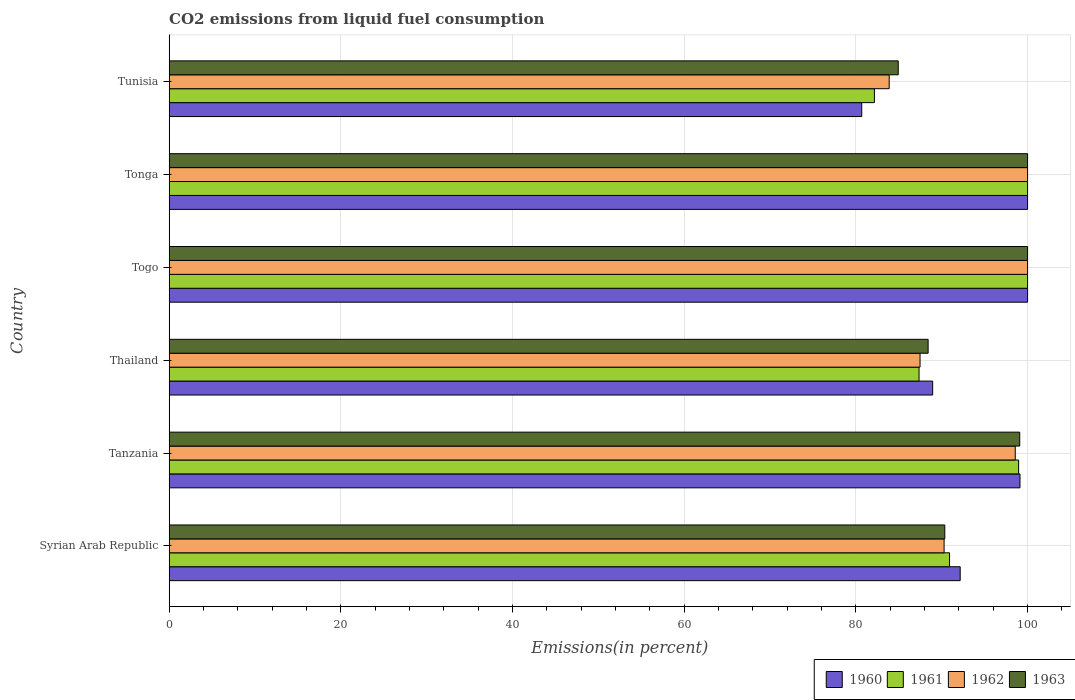How many different coloured bars are there?
Make the answer very short. 4. Are the number of bars per tick equal to the number of legend labels?
Give a very brief answer. Yes. What is the label of the 6th group of bars from the top?
Offer a very short reply. Syrian Arab Republic. In how many cases, is the number of bars for a given country not equal to the number of legend labels?
Keep it short and to the point. 0. Across all countries, what is the maximum total CO2 emitted in 1963?
Keep it short and to the point. 100. Across all countries, what is the minimum total CO2 emitted in 1962?
Your response must be concise. 83.88. In which country was the total CO2 emitted in 1962 maximum?
Your answer should be very brief. Togo. In which country was the total CO2 emitted in 1961 minimum?
Offer a very short reply. Tunisia. What is the total total CO2 emitted in 1960 in the graph?
Your response must be concise. 560.89. What is the difference between the total CO2 emitted in 1961 in Tanzania and that in Thailand?
Provide a succinct answer. 11.6. What is the difference between the total CO2 emitted in 1961 in Togo and the total CO2 emitted in 1962 in Thailand?
Your answer should be very brief. 12.53. What is the average total CO2 emitted in 1960 per country?
Offer a terse response. 93.48. What is the difference between the total CO2 emitted in 1960 and total CO2 emitted in 1961 in Syrian Arab Republic?
Offer a very short reply. 1.24. In how many countries, is the total CO2 emitted in 1960 greater than 72 %?
Your answer should be compact. 6. What is the ratio of the total CO2 emitted in 1963 in Thailand to that in Tunisia?
Ensure brevity in your answer.  1.04. Is the difference between the total CO2 emitted in 1960 in Thailand and Togo greater than the difference between the total CO2 emitted in 1961 in Thailand and Togo?
Give a very brief answer. Yes. What is the difference between the highest and the lowest total CO2 emitted in 1961?
Your answer should be very brief. 17.84. Is it the case that in every country, the sum of the total CO2 emitted in 1961 and total CO2 emitted in 1962 is greater than the total CO2 emitted in 1963?
Ensure brevity in your answer.  Yes. How many countries are there in the graph?
Your answer should be compact. 6. What is the difference between two consecutive major ticks on the X-axis?
Your answer should be compact. 20. Are the values on the major ticks of X-axis written in scientific E-notation?
Offer a very short reply. No. Does the graph contain any zero values?
Make the answer very short. No. Where does the legend appear in the graph?
Provide a short and direct response. Bottom right. How many legend labels are there?
Provide a succinct answer. 4. What is the title of the graph?
Your answer should be compact. CO2 emissions from liquid fuel consumption. Does "1962" appear as one of the legend labels in the graph?
Your answer should be compact. Yes. What is the label or title of the X-axis?
Provide a succinct answer. Emissions(in percent). What is the label or title of the Y-axis?
Your response must be concise. Country. What is the Emissions(in percent) of 1960 in Syrian Arab Republic?
Your answer should be very brief. 92.15. What is the Emissions(in percent) in 1961 in Syrian Arab Republic?
Your response must be concise. 90.91. What is the Emissions(in percent) of 1962 in Syrian Arab Republic?
Give a very brief answer. 90.27. What is the Emissions(in percent) in 1963 in Syrian Arab Republic?
Give a very brief answer. 90.36. What is the Emissions(in percent) of 1960 in Tanzania?
Make the answer very short. 99.12. What is the Emissions(in percent) of 1961 in Tanzania?
Your answer should be very brief. 98.96. What is the Emissions(in percent) in 1962 in Tanzania?
Ensure brevity in your answer.  98.56. What is the Emissions(in percent) of 1963 in Tanzania?
Offer a very short reply. 99.09. What is the Emissions(in percent) in 1960 in Thailand?
Make the answer very short. 88.94. What is the Emissions(in percent) in 1961 in Thailand?
Keep it short and to the point. 87.36. What is the Emissions(in percent) in 1962 in Thailand?
Your answer should be compact. 87.47. What is the Emissions(in percent) in 1963 in Thailand?
Provide a short and direct response. 88.41. What is the Emissions(in percent) of 1960 in Togo?
Give a very brief answer. 100. What is the Emissions(in percent) in 1961 in Tonga?
Offer a terse response. 100. What is the Emissions(in percent) of 1963 in Tonga?
Keep it short and to the point. 100. What is the Emissions(in percent) in 1960 in Tunisia?
Offer a very short reply. 80.68. What is the Emissions(in percent) of 1961 in Tunisia?
Ensure brevity in your answer.  82.16. What is the Emissions(in percent) in 1962 in Tunisia?
Your response must be concise. 83.88. What is the Emissions(in percent) of 1963 in Tunisia?
Offer a terse response. 84.93. Across all countries, what is the maximum Emissions(in percent) in 1961?
Give a very brief answer. 100. Across all countries, what is the maximum Emissions(in percent) in 1963?
Your response must be concise. 100. Across all countries, what is the minimum Emissions(in percent) in 1960?
Keep it short and to the point. 80.68. Across all countries, what is the minimum Emissions(in percent) of 1961?
Your response must be concise. 82.16. Across all countries, what is the minimum Emissions(in percent) in 1962?
Keep it short and to the point. 83.88. Across all countries, what is the minimum Emissions(in percent) of 1963?
Make the answer very short. 84.93. What is the total Emissions(in percent) of 1960 in the graph?
Make the answer very short. 560.89. What is the total Emissions(in percent) of 1961 in the graph?
Ensure brevity in your answer.  559.38. What is the total Emissions(in percent) of 1962 in the graph?
Provide a succinct answer. 560.19. What is the total Emissions(in percent) of 1963 in the graph?
Give a very brief answer. 562.79. What is the difference between the Emissions(in percent) in 1960 in Syrian Arab Republic and that in Tanzania?
Provide a succinct answer. -6.96. What is the difference between the Emissions(in percent) of 1961 in Syrian Arab Republic and that in Tanzania?
Give a very brief answer. -8.05. What is the difference between the Emissions(in percent) of 1962 in Syrian Arab Republic and that in Tanzania?
Give a very brief answer. -8.29. What is the difference between the Emissions(in percent) of 1963 in Syrian Arab Republic and that in Tanzania?
Offer a very short reply. -8.73. What is the difference between the Emissions(in percent) of 1960 in Syrian Arab Republic and that in Thailand?
Give a very brief answer. 3.21. What is the difference between the Emissions(in percent) in 1961 in Syrian Arab Republic and that in Thailand?
Ensure brevity in your answer.  3.55. What is the difference between the Emissions(in percent) of 1962 in Syrian Arab Republic and that in Thailand?
Your answer should be compact. 2.8. What is the difference between the Emissions(in percent) in 1963 in Syrian Arab Republic and that in Thailand?
Offer a very short reply. 1.94. What is the difference between the Emissions(in percent) in 1960 in Syrian Arab Republic and that in Togo?
Ensure brevity in your answer.  -7.85. What is the difference between the Emissions(in percent) of 1961 in Syrian Arab Republic and that in Togo?
Your answer should be compact. -9.09. What is the difference between the Emissions(in percent) in 1962 in Syrian Arab Republic and that in Togo?
Give a very brief answer. -9.73. What is the difference between the Emissions(in percent) in 1963 in Syrian Arab Republic and that in Togo?
Your answer should be compact. -9.64. What is the difference between the Emissions(in percent) of 1960 in Syrian Arab Republic and that in Tonga?
Offer a terse response. -7.85. What is the difference between the Emissions(in percent) in 1961 in Syrian Arab Republic and that in Tonga?
Ensure brevity in your answer.  -9.09. What is the difference between the Emissions(in percent) in 1962 in Syrian Arab Republic and that in Tonga?
Ensure brevity in your answer.  -9.73. What is the difference between the Emissions(in percent) in 1963 in Syrian Arab Republic and that in Tonga?
Keep it short and to the point. -9.64. What is the difference between the Emissions(in percent) of 1960 in Syrian Arab Republic and that in Tunisia?
Provide a short and direct response. 11.47. What is the difference between the Emissions(in percent) in 1961 in Syrian Arab Republic and that in Tunisia?
Offer a very short reply. 8.75. What is the difference between the Emissions(in percent) of 1962 in Syrian Arab Republic and that in Tunisia?
Your answer should be very brief. 6.4. What is the difference between the Emissions(in percent) in 1963 in Syrian Arab Republic and that in Tunisia?
Your answer should be very brief. 5.42. What is the difference between the Emissions(in percent) of 1960 in Tanzania and that in Thailand?
Give a very brief answer. 10.17. What is the difference between the Emissions(in percent) in 1961 in Tanzania and that in Thailand?
Ensure brevity in your answer.  11.6. What is the difference between the Emissions(in percent) in 1962 in Tanzania and that in Thailand?
Your response must be concise. 11.09. What is the difference between the Emissions(in percent) in 1963 in Tanzania and that in Thailand?
Give a very brief answer. 10.67. What is the difference between the Emissions(in percent) in 1960 in Tanzania and that in Togo?
Ensure brevity in your answer.  -0.89. What is the difference between the Emissions(in percent) in 1961 in Tanzania and that in Togo?
Provide a succinct answer. -1.04. What is the difference between the Emissions(in percent) of 1962 in Tanzania and that in Togo?
Provide a succinct answer. -1.44. What is the difference between the Emissions(in percent) of 1963 in Tanzania and that in Togo?
Offer a terse response. -0.91. What is the difference between the Emissions(in percent) in 1960 in Tanzania and that in Tonga?
Make the answer very short. -0.89. What is the difference between the Emissions(in percent) of 1961 in Tanzania and that in Tonga?
Provide a succinct answer. -1.04. What is the difference between the Emissions(in percent) of 1962 in Tanzania and that in Tonga?
Ensure brevity in your answer.  -1.44. What is the difference between the Emissions(in percent) in 1963 in Tanzania and that in Tonga?
Provide a succinct answer. -0.91. What is the difference between the Emissions(in percent) of 1960 in Tanzania and that in Tunisia?
Make the answer very short. 18.44. What is the difference between the Emissions(in percent) of 1961 in Tanzania and that in Tunisia?
Provide a succinct answer. 16.8. What is the difference between the Emissions(in percent) of 1962 in Tanzania and that in Tunisia?
Your answer should be compact. 14.69. What is the difference between the Emissions(in percent) of 1963 in Tanzania and that in Tunisia?
Make the answer very short. 14.15. What is the difference between the Emissions(in percent) of 1960 in Thailand and that in Togo?
Your response must be concise. -11.06. What is the difference between the Emissions(in percent) in 1961 in Thailand and that in Togo?
Your answer should be very brief. -12.64. What is the difference between the Emissions(in percent) in 1962 in Thailand and that in Togo?
Your response must be concise. -12.53. What is the difference between the Emissions(in percent) of 1963 in Thailand and that in Togo?
Your answer should be very brief. -11.59. What is the difference between the Emissions(in percent) of 1960 in Thailand and that in Tonga?
Make the answer very short. -11.06. What is the difference between the Emissions(in percent) of 1961 in Thailand and that in Tonga?
Keep it short and to the point. -12.64. What is the difference between the Emissions(in percent) in 1962 in Thailand and that in Tonga?
Give a very brief answer. -12.53. What is the difference between the Emissions(in percent) of 1963 in Thailand and that in Tonga?
Give a very brief answer. -11.59. What is the difference between the Emissions(in percent) of 1960 in Thailand and that in Tunisia?
Give a very brief answer. 8.26. What is the difference between the Emissions(in percent) of 1961 in Thailand and that in Tunisia?
Offer a terse response. 5.2. What is the difference between the Emissions(in percent) in 1962 in Thailand and that in Tunisia?
Your answer should be very brief. 3.6. What is the difference between the Emissions(in percent) in 1963 in Thailand and that in Tunisia?
Keep it short and to the point. 3.48. What is the difference between the Emissions(in percent) in 1961 in Togo and that in Tonga?
Give a very brief answer. 0. What is the difference between the Emissions(in percent) in 1960 in Togo and that in Tunisia?
Provide a succinct answer. 19.32. What is the difference between the Emissions(in percent) of 1961 in Togo and that in Tunisia?
Keep it short and to the point. 17.84. What is the difference between the Emissions(in percent) of 1962 in Togo and that in Tunisia?
Give a very brief answer. 16.12. What is the difference between the Emissions(in percent) of 1963 in Togo and that in Tunisia?
Offer a very short reply. 15.07. What is the difference between the Emissions(in percent) of 1960 in Tonga and that in Tunisia?
Your answer should be compact. 19.32. What is the difference between the Emissions(in percent) in 1961 in Tonga and that in Tunisia?
Your answer should be very brief. 17.84. What is the difference between the Emissions(in percent) in 1962 in Tonga and that in Tunisia?
Make the answer very short. 16.12. What is the difference between the Emissions(in percent) in 1963 in Tonga and that in Tunisia?
Offer a very short reply. 15.07. What is the difference between the Emissions(in percent) of 1960 in Syrian Arab Republic and the Emissions(in percent) of 1961 in Tanzania?
Provide a succinct answer. -6.81. What is the difference between the Emissions(in percent) of 1960 in Syrian Arab Republic and the Emissions(in percent) of 1962 in Tanzania?
Your answer should be compact. -6.41. What is the difference between the Emissions(in percent) in 1960 in Syrian Arab Republic and the Emissions(in percent) in 1963 in Tanzania?
Make the answer very short. -6.94. What is the difference between the Emissions(in percent) in 1961 in Syrian Arab Republic and the Emissions(in percent) in 1962 in Tanzania?
Offer a very short reply. -7.66. What is the difference between the Emissions(in percent) of 1961 in Syrian Arab Republic and the Emissions(in percent) of 1963 in Tanzania?
Give a very brief answer. -8.18. What is the difference between the Emissions(in percent) in 1962 in Syrian Arab Republic and the Emissions(in percent) in 1963 in Tanzania?
Ensure brevity in your answer.  -8.81. What is the difference between the Emissions(in percent) in 1960 in Syrian Arab Republic and the Emissions(in percent) in 1961 in Thailand?
Offer a very short reply. 4.79. What is the difference between the Emissions(in percent) of 1960 in Syrian Arab Republic and the Emissions(in percent) of 1962 in Thailand?
Offer a very short reply. 4.68. What is the difference between the Emissions(in percent) in 1960 in Syrian Arab Republic and the Emissions(in percent) in 1963 in Thailand?
Ensure brevity in your answer.  3.74. What is the difference between the Emissions(in percent) of 1961 in Syrian Arab Republic and the Emissions(in percent) of 1962 in Thailand?
Your answer should be compact. 3.44. What is the difference between the Emissions(in percent) of 1961 in Syrian Arab Republic and the Emissions(in percent) of 1963 in Thailand?
Your answer should be very brief. 2.5. What is the difference between the Emissions(in percent) in 1962 in Syrian Arab Republic and the Emissions(in percent) in 1963 in Thailand?
Keep it short and to the point. 1.86. What is the difference between the Emissions(in percent) of 1960 in Syrian Arab Republic and the Emissions(in percent) of 1961 in Togo?
Make the answer very short. -7.85. What is the difference between the Emissions(in percent) in 1960 in Syrian Arab Republic and the Emissions(in percent) in 1962 in Togo?
Provide a succinct answer. -7.85. What is the difference between the Emissions(in percent) of 1960 in Syrian Arab Republic and the Emissions(in percent) of 1963 in Togo?
Offer a terse response. -7.85. What is the difference between the Emissions(in percent) of 1961 in Syrian Arab Republic and the Emissions(in percent) of 1962 in Togo?
Ensure brevity in your answer.  -9.09. What is the difference between the Emissions(in percent) of 1961 in Syrian Arab Republic and the Emissions(in percent) of 1963 in Togo?
Offer a very short reply. -9.09. What is the difference between the Emissions(in percent) in 1962 in Syrian Arab Republic and the Emissions(in percent) in 1963 in Togo?
Provide a short and direct response. -9.73. What is the difference between the Emissions(in percent) in 1960 in Syrian Arab Republic and the Emissions(in percent) in 1961 in Tonga?
Your answer should be very brief. -7.85. What is the difference between the Emissions(in percent) of 1960 in Syrian Arab Republic and the Emissions(in percent) of 1962 in Tonga?
Your answer should be very brief. -7.85. What is the difference between the Emissions(in percent) in 1960 in Syrian Arab Republic and the Emissions(in percent) in 1963 in Tonga?
Offer a very short reply. -7.85. What is the difference between the Emissions(in percent) in 1961 in Syrian Arab Republic and the Emissions(in percent) in 1962 in Tonga?
Keep it short and to the point. -9.09. What is the difference between the Emissions(in percent) of 1961 in Syrian Arab Republic and the Emissions(in percent) of 1963 in Tonga?
Make the answer very short. -9.09. What is the difference between the Emissions(in percent) in 1962 in Syrian Arab Republic and the Emissions(in percent) in 1963 in Tonga?
Your response must be concise. -9.73. What is the difference between the Emissions(in percent) in 1960 in Syrian Arab Republic and the Emissions(in percent) in 1961 in Tunisia?
Your answer should be very brief. 9.99. What is the difference between the Emissions(in percent) of 1960 in Syrian Arab Republic and the Emissions(in percent) of 1962 in Tunisia?
Offer a terse response. 8.27. What is the difference between the Emissions(in percent) in 1960 in Syrian Arab Republic and the Emissions(in percent) in 1963 in Tunisia?
Keep it short and to the point. 7.22. What is the difference between the Emissions(in percent) of 1961 in Syrian Arab Republic and the Emissions(in percent) of 1962 in Tunisia?
Offer a terse response. 7.03. What is the difference between the Emissions(in percent) in 1961 in Syrian Arab Republic and the Emissions(in percent) in 1963 in Tunisia?
Offer a terse response. 5.97. What is the difference between the Emissions(in percent) of 1962 in Syrian Arab Republic and the Emissions(in percent) of 1963 in Tunisia?
Keep it short and to the point. 5.34. What is the difference between the Emissions(in percent) of 1960 in Tanzania and the Emissions(in percent) of 1961 in Thailand?
Provide a short and direct response. 11.76. What is the difference between the Emissions(in percent) in 1960 in Tanzania and the Emissions(in percent) in 1962 in Thailand?
Make the answer very short. 11.64. What is the difference between the Emissions(in percent) in 1960 in Tanzania and the Emissions(in percent) in 1963 in Thailand?
Your answer should be very brief. 10.7. What is the difference between the Emissions(in percent) of 1961 in Tanzania and the Emissions(in percent) of 1962 in Thailand?
Your answer should be very brief. 11.49. What is the difference between the Emissions(in percent) in 1961 in Tanzania and the Emissions(in percent) in 1963 in Thailand?
Offer a very short reply. 10.54. What is the difference between the Emissions(in percent) of 1962 in Tanzania and the Emissions(in percent) of 1963 in Thailand?
Your response must be concise. 10.15. What is the difference between the Emissions(in percent) in 1960 in Tanzania and the Emissions(in percent) in 1961 in Togo?
Offer a terse response. -0.89. What is the difference between the Emissions(in percent) of 1960 in Tanzania and the Emissions(in percent) of 1962 in Togo?
Ensure brevity in your answer.  -0.89. What is the difference between the Emissions(in percent) of 1960 in Tanzania and the Emissions(in percent) of 1963 in Togo?
Ensure brevity in your answer.  -0.89. What is the difference between the Emissions(in percent) in 1961 in Tanzania and the Emissions(in percent) in 1962 in Togo?
Keep it short and to the point. -1.04. What is the difference between the Emissions(in percent) of 1961 in Tanzania and the Emissions(in percent) of 1963 in Togo?
Your answer should be compact. -1.04. What is the difference between the Emissions(in percent) of 1962 in Tanzania and the Emissions(in percent) of 1963 in Togo?
Your response must be concise. -1.44. What is the difference between the Emissions(in percent) in 1960 in Tanzania and the Emissions(in percent) in 1961 in Tonga?
Provide a short and direct response. -0.89. What is the difference between the Emissions(in percent) in 1960 in Tanzania and the Emissions(in percent) in 1962 in Tonga?
Offer a terse response. -0.89. What is the difference between the Emissions(in percent) in 1960 in Tanzania and the Emissions(in percent) in 1963 in Tonga?
Your answer should be very brief. -0.89. What is the difference between the Emissions(in percent) of 1961 in Tanzania and the Emissions(in percent) of 1962 in Tonga?
Ensure brevity in your answer.  -1.04. What is the difference between the Emissions(in percent) of 1961 in Tanzania and the Emissions(in percent) of 1963 in Tonga?
Keep it short and to the point. -1.04. What is the difference between the Emissions(in percent) of 1962 in Tanzania and the Emissions(in percent) of 1963 in Tonga?
Offer a very short reply. -1.44. What is the difference between the Emissions(in percent) in 1960 in Tanzania and the Emissions(in percent) in 1961 in Tunisia?
Keep it short and to the point. 16.96. What is the difference between the Emissions(in percent) of 1960 in Tanzania and the Emissions(in percent) of 1962 in Tunisia?
Offer a very short reply. 15.24. What is the difference between the Emissions(in percent) of 1960 in Tanzania and the Emissions(in percent) of 1963 in Tunisia?
Give a very brief answer. 14.18. What is the difference between the Emissions(in percent) in 1961 in Tanzania and the Emissions(in percent) in 1962 in Tunisia?
Your answer should be very brief. 15.08. What is the difference between the Emissions(in percent) of 1961 in Tanzania and the Emissions(in percent) of 1963 in Tunisia?
Your answer should be compact. 14.02. What is the difference between the Emissions(in percent) in 1962 in Tanzania and the Emissions(in percent) in 1963 in Tunisia?
Provide a succinct answer. 13.63. What is the difference between the Emissions(in percent) of 1960 in Thailand and the Emissions(in percent) of 1961 in Togo?
Provide a succinct answer. -11.06. What is the difference between the Emissions(in percent) in 1960 in Thailand and the Emissions(in percent) in 1962 in Togo?
Your response must be concise. -11.06. What is the difference between the Emissions(in percent) in 1960 in Thailand and the Emissions(in percent) in 1963 in Togo?
Your response must be concise. -11.06. What is the difference between the Emissions(in percent) of 1961 in Thailand and the Emissions(in percent) of 1962 in Togo?
Your answer should be compact. -12.64. What is the difference between the Emissions(in percent) of 1961 in Thailand and the Emissions(in percent) of 1963 in Togo?
Offer a very short reply. -12.64. What is the difference between the Emissions(in percent) of 1962 in Thailand and the Emissions(in percent) of 1963 in Togo?
Provide a succinct answer. -12.53. What is the difference between the Emissions(in percent) of 1960 in Thailand and the Emissions(in percent) of 1961 in Tonga?
Your response must be concise. -11.06. What is the difference between the Emissions(in percent) of 1960 in Thailand and the Emissions(in percent) of 1962 in Tonga?
Your answer should be compact. -11.06. What is the difference between the Emissions(in percent) of 1960 in Thailand and the Emissions(in percent) of 1963 in Tonga?
Provide a succinct answer. -11.06. What is the difference between the Emissions(in percent) in 1961 in Thailand and the Emissions(in percent) in 1962 in Tonga?
Offer a terse response. -12.64. What is the difference between the Emissions(in percent) of 1961 in Thailand and the Emissions(in percent) of 1963 in Tonga?
Your answer should be compact. -12.64. What is the difference between the Emissions(in percent) of 1962 in Thailand and the Emissions(in percent) of 1963 in Tonga?
Your response must be concise. -12.53. What is the difference between the Emissions(in percent) of 1960 in Thailand and the Emissions(in percent) of 1961 in Tunisia?
Keep it short and to the point. 6.79. What is the difference between the Emissions(in percent) of 1960 in Thailand and the Emissions(in percent) of 1962 in Tunisia?
Provide a succinct answer. 5.07. What is the difference between the Emissions(in percent) in 1960 in Thailand and the Emissions(in percent) in 1963 in Tunisia?
Provide a short and direct response. 4.01. What is the difference between the Emissions(in percent) in 1961 in Thailand and the Emissions(in percent) in 1962 in Tunisia?
Provide a succinct answer. 3.48. What is the difference between the Emissions(in percent) in 1961 in Thailand and the Emissions(in percent) in 1963 in Tunisia?
Make the answer very short. 2.42. What is the difference between the Emissions(in percent) of 1962 in Thailand and the Emissions(in percent) of 1963 in Tunisia?
Make the answer very short. 2.54. What is the difference between the Emissions(in percent) in 1962 in Togo and the Emissions(in percent) in 1963 in Tonga?
Provide a succinct answer. 0. What is the difference between the Emissions(in percent) in 1960 in Togo and the Emissions(in percent) in 1961 in Tunisia?
Keep it short and to the point. 17.84. What is the difference between the Emissions(in percent) in 1960 in Togo and the Emissions(in percent) in 1962 in Tunisia?
Provide a short and direct response. 16.12. What is the difference between the Emissions(in percent) in 1960 in Togo and the Emissions(in percent) in 1963 in Tunisia?
Provide a succinct answer. 15.07. What is the difference between the Emissions(in percent) of 1961 in Togo and the Emissions(in percent) of 1962 in Tunisia?
Offer a terse response. 16.12. What is the difference between the Emissions(in percent) in 1961 in Togo and the Emissions(in percent) in 1963 in Tunisia?
Your response must be concise. 15.07. What is the difference between the Emissions(in percent) of 1962 in Togo and the Emissions(in percent) of 1963 in Tunisia?
Your answer should be compact. 15.07. What is the difference between the Emissions(in percent) in 1960 in Tonga and the Emissions(in percent) in 1961 in Tunisia?
Offer a terse response. 17.84. What is the difference between the Emissions(in percent) of 1960 in Tonga and the Emissions(in percent) of 1962 in Tunisia?
Offer a terse response. 16.12. What is the difference between the Emissions(in percent) of 1960 in Tonga and the Emissions(in percent) of 1963 in Tunisia?
Make the answer very short. 15.07. What is the difference between the Emissions(in percent) in 1961 in Tonga and the Emissions(in percent) in 1962 in Tunisia?
Your response must be concise. 16.12. What is the difference between the Emissions(in percent) in 1961 in Tonga and the Emissions(in percent) in 1963 in Tunisia?
Provide a short and direct response. 15.07. What is the difference between the Emissions(in percent) in 1962 in Tonga and the Emissions(in percent) in 1963 in Tunisia?
Provide a succinct answer. 15.07. What is the average Emissions(in percent) in 1960 per country?
Your response must be concise. 93.48. What is the average Emissions(in percent) in 1961 per country?
Provide a short and direct response. 93.23. What is the average Emissions(in percent) of 1962 per country?
Provide a short and direct response. 93.36. What is the average Emissions(in percent) in 1963 per country?
Ensure brevity in your answer.  93.8. What is the difference between the Emissions(in percent) of 1960 and Emissions(in percent) of 1961 in Syrian Arab Republic?
Make the answer very short. 1.24. What is the difference between the Emissions(in percent) of 1960 and Emissions(in percent) of 1962 in Syrian Arab Republic?
Your response must be concise. 1.88. What is the difference between the Emissions(in percent) in 1960 and Emissions(in percent) in 1963 in Syrian Arab Republic?
Your answer should be very brief. 1.79. What is the difference between the Emissions(in percent) of 1961 and Emissions(in percent) of 1962 in Syrian Arab Republic?
Provide a short and direct response. 0.63. What is the difference between the Emissions(in percent) of 1961 and Emissions(in percent) of 1963 in Syrian Arab Republic?
Your answer should be compact. 0.55. What is the difference between the Emissions(in percent) of 1962 and Emissions(in percent) of 1963 in Syrian Arab Republic?
Your answer should be very brief. -0.08. What is the difference between the Emissions(in percent) of 1960 and Emissions(in percent) of 1961 in Tanzania?
Your answer should be very brief. 0.16. What is the difference between the Emissions(in percent) in 1960 and Emissions(in percent) in 1962 in Tanzania?
Your answer should be very brief. 0.55. What is the difference between the Emissions(in percent) in 1960 and Emissions(in percent) in 1963 in Tanzania?
Your answer should be very brief. 0.03. What is the difference between the Emissions(in percent) in 1961 and Emissions(in percent) in 1962 in Tanzania?
Your answer should be compact. 0.39. What is the difference between the Emissions(in percent) in 1961 and Emissions(in percent) in 1963 in Tanzania?
Ensure brevity in your answer.  -0.13. What is the difference between the Emissions(in percent) of 1962 and Emissions(in percent) of 1963 in Tanzania?
Your answer should be very brief. -0.52. What is the difference between the Emissions(in percent) of 1960 and Emissions(in percent) of 1961 in Thailand?
Keep it short and to the point. 1.59. What is the difference between the Emissions(in percent) in 1960 and Emissions(in percent) in 1962 in Thailand?
Your response must be concise. 1.47. What is the difference between the Emissions(in percent) in 1960 and Emissions(in percent) in 1963 in Thailand?
Provide a succinct answer. 0.53. What is the difference between the Emissions(in percent) of 1961 and Emissions(in percent) of 1962 in Thailand?
Keep it short and to the point. -0.12. What is the difference between the Emissions(in percent) in 1961 and Emissions(in percent) in 1963 in Thailand?
Offer a very short reply. -1.06. What is the difference between the Emissions(in percent) of 1962 and Emissions(in percent) of 1963 in Thailand?
Your response must be concise. -0.94. What is the difference between the Emissions(in percent) in 1960 and Emissions(in percent) in 1963 in Togo?
Provide a short and direct response. 0. What is the difference between the Emissions(in percent) in 1961 and Emissions(in percent) in 1963 in Togo?
Offer a very short reply. 0. What is the difference between the Emissions(in percent) of 1962 and Emissions(in percent) of 1963 in Togo?
Provide a short and direct response. 0. What is the difference between the Emissions(in percent) in 1960 and Emissions(in percent) in 1961 in Tonga?
Offer a very short reply. 0. What is the difference between the Emissions(in percent) of 1960 and Emissions(in percent) of 1962 in Tonga?
Offer a terse response. 0. What is the difference between the Emissions(in percent) in 1961 and Emissions(in percent) in 1962 in Tonga?
Your answer should be very brief. 0. What is the difference between the Emissions(in percent) in 1961 and Emissions(in percent) in 1963 in Tonga?
Offer a terse response. 0. What is the difference between the Emissions(in percent) in 1960 and Emissions(in percent) in 1961 in Tunisia?
Your response must be concise. -1.48. What is the difference between the Emissions(in percent) of 1960 and Emissions(in percent) of 1962 in Tunisia?
Ensure brevity in your answer.  -3.2. What is the difference between the Emissions(in percent) in 1960 and Emissions(in percent) in 1963 in Tunisia?
Your response must be concise. -4.25. What is the difference between the Emissions(in percent) of 1961 and Emissions(in percent) of 1962 in Tunisia?
Offer a terse response. -1.72. What is the difference between the Emissions(in percent) in 1961 and Emissions(in percent) in 1963 in Tunisia?
Provide a succinct answer. -2.78. What is the difference between the Emissions(in percent) in 1962 and Emissions(in percent) in 1963 in Tunisia?
Offer a very short reply. -1.06. What is the ratio of the Emissions(in percent) in 1960 in Syrian Arab Republic to that in Tanzania?
Ensure brevity in your answer.  0.93. What is the ratio of the Emissions(in percent) in 1961 in Syrian Arab Republic to that in Tanzania?
Your response must be concise. 0.92. What is the ratio of the Emissions(in percent) of 1962 in Syrian Arab Republic to that in Tanzania?
Make the answer very short. 0.92. What is the ratio of the Emissions(in percent) in 1963 in Syrian Arab Republic to that in Tanzania?
Ensure brevity in your answer.  0.91. What is the ratio of the Emissions(in percent) in 1960 in Syrian Arab Republic to that in Thailand?
Provide a succinct answer. 1.04. What is the ratio of the Emissions(in percent) in 1961 in Syrian Arab Republic to that in Thailand?
Make the answer very short. 1.04. What is the ratio of the Emissions(in percent) of 1962 in Syrian Arab Republic to that in Thailand?
Ensure brevity in your answer.  1.03. What is the ratio of the Emissions(in percent) of 1960 in Syrian Arab Republic to that in Togo?
Give a very brief answer. 0.92. What is the ratio of the Emissions(in percent) in 1962 in Syrian Arab Republic to that in Togo?
Provide a succinct answer. 0.9. What is the ratio of the Emissions(in percent) of 1963 in Syrian Arab Republic to that in Togo?
Give a very brief answer. 0.9. What is the ratio of the Emissions(in percent) of 1960 in Syrian Arab Republic to that in Tonga?
Your answer should be very brief. 0.92. What is the ratio of the Emissions(in percent) of 1961 in Syrian Arab Republic to that in Tonga?
Your answer should be very brief. 0.91. What is the ratio of the Emissions(in percent) in 1962 in Syrian Arab Republic to that in Tonga?
Provide a succinct answer. 0.9. What is the ratio of the Emissions(in percent) of 1963 in Syrian Arab Republic to that in Tonga?
Ensure brevity in your answer.  0.9. What is the ratio of the Emissions(in percent) of 1960 in Syrian Arab Republic to that in Tunisia?
Give a very brief answer. 1.14. What is the ratio of the Emissions(in percent) in 1961 in Syrian Arab Republic to that in Tunisia?
Your answer should be compact. 1.11. What is the ratio of the Emissions(in percent) in 1962 in Syrian Arab Republic to that in Tunisia?
Ensure brevity in your answer.  1.08. What is the ratio of the Emissions(in percent) of 1963 in Syrian Arab Republic to that in Tunisia?
Offer a very short reply. 1.06. What is the ratio of the Emissions(in percent) in 1960 in Tanzania to that in Thailand?
Your answer should be very brief. 1.11. What is the ratio of the Emissions(in percent) in 1961 in Tanzania to that in Thailand?
Your response must be concise. 1.13. What is the ratio of the Emissions(in percent) in 1962 in Tanzania to that in Thailand?
Offer a very short reply. 1.13. What is the ratio of the Emissions(in percent) in 1963 in Tanzania to that in Thailand?
Your answer should be very brief. 1.12. What is the ratio of the Emissions(in percent) of 1960 in Tanzania to that in Togo?
Offer a very short reply. 0.99. What is the ratio of the Emissions(in percent) in 1961 in Tanzania to that in Togo?
Make the answer very short. 0.99. What is the ratio of the Emissions(in percent) of 1962 in Tanzania to that in Togo?
Your answer should be very brief. 0.99. What is the ratio of the Emissions(in percent) in 1963 in Tanzania to that in Togo?
Your answer should be very brief. 0.99. What is the ratio of the Emissions(in percent) of 1960 in Tanzania to that in Tonga?
Provide a succinct answer. 0.99. What is the ratio of the Emissions(in percent) in 1961 in Tanzania to that in Tonga?
Provide a succinct answer. 0.99. What is the ratio of the Emissions(in percent) in 1962 in Tanzania to that in Tonga?
Provide a succinct answer. 0.99. What is the ratio of the Emissions(in percent) in 1963 in Tanzania to that in Tonga?
Give a very brief answer. 0.99. What is the ratio of the Emissions(in percent) of 1960 in Tanzania to that in Tunisia?
Keep it short and to the point. 1.23. What is the ratio of the Emissions(in percent) in 1961 in Tanzania to that in Tunisia?
Make the answer very short. 1.2. What is the ratio of the Emissions(in percent) in 1962 in Tanzania to that in Tunisia?
Ensure brevity in your answer.  1.18. What is the ratio of the Emissions(in percent) of 1963 in Tanzania to that in Tunisia?
Your response must be concise. 1.17. What is the ratio of the Emissions(in percent) of 1960 in Thailand to that in Togo?
Ensure brevity in your answer.  0.89. What is the ratio of the Emissions(in percent) of 1961 in Thailand to that in Togo?
Provide a succinct answer. 0.87. What is the ratio of the Emissions(in percent) in 1962 in Thailand to that in Togo?
Provide a short and direct response. 0.87. What is the ratio of the Emissions(in percent) in 1963 in Thailand to that in Togo?
Ensure brevity in your answer.  0.88. What is the ratio of the Emissions(in percent) of 1960 in Thailand to that in Tonga?
Provide a short and direct response. 0.89. What is the ratio of the Emissions(in percent) of 1961 in Thailand to that in Tonga?
Your response must be concise. 0.87. What is the ratio of the Emissions(in percent) of 1962 in Thailand to that in Tonga?
Offer a very short reply. 0.87. What is the ratio of the Emissions(in percent) of 1963 in Thailand to that in Tonga?
Ensure brevity in your answer.  0.88. What is the ratio of the Emissions(in percent) in 1960 in Thailand to that in Tunisia?
Offer a terse response. 1.1. What is the ratio of the Emissions(in percent) of 1961 in Thailand to that in Tunisia?
Ensure brevity in your answer.  1.06. What is the ratio of the Emissions(in percent) of 1962 in Thailand to that in Tunisia?
Make the answer very short. 1.04. What is the ratio of the Emissions(in percent) of 1963 in Thailand to that in Tunisia?
Provide a short and direct response. 1.04. What is the ratio of the Emissions(in percent) in 1961 in Togo to that in Tonga?
Offer a very short reply. 1. What is the ratio of the Emissions(in percent) of 1960 in Togo to that in Tunisia?
Keep it short and to the point. 1.24. What is the ratio of the Emissions(in percent) of 1961 in Togo to that in Tunisia?
Offer a very short reply. 1.22. What is the ratio of the Emissions(in percent) in 1962 in Togo to that in Tunisia?
Your response must be concise. 1.19. What is the ratio of the Emissions(in percent) in 1963 in Togo to that in Tunisia?
Provide a succinct answer. 1.18. What is the ratio of the Emissions(in percent) of 1960 in Tonga to that in Tunisia?
Provide a succinct answer. 1.24. What is the ratio of the Emissions(in percent) in 1961 in Tonga to that in Tunisia?
Your answer should be very brief. 1.22. What is the ratio of the Emissions(in percent) of 1962 in Tonga to that in Tunisia?
Give a very brief answer. 1.19. What is the ratio of the Emissions(in percent) of 1963 in Tonga to that in Tunisia?
Your answer should be very brief. 1.18. What is the difference between the highest and the second highest Emissions(in percent) of 1960?
Provide a succinct answer. 0. What is the difference between the highest and the second highest Emissions(in percent) in 1961?
Your answer should be very brief. 0. What is the difference between the highest and the second highest Emissions(in percent) of 1962?
Make the answer very short. 0. What is the difference between the highest and the lowest Emissions(in percent) of 1960?
Ensure brevity in your answer.  19.32. What is the difference between the highest and the lowest Emissions(in percent) in 1961?
Your answer should be compact. 17.84. What is the difference between the highest and the lowest Emissions(in percent) of 1962?
Keep it short and to the point. 16.12. What is the difference between the highest and the lowest Emissions(in percent) in 1963?
Provide a succinct answer. 15.07. 